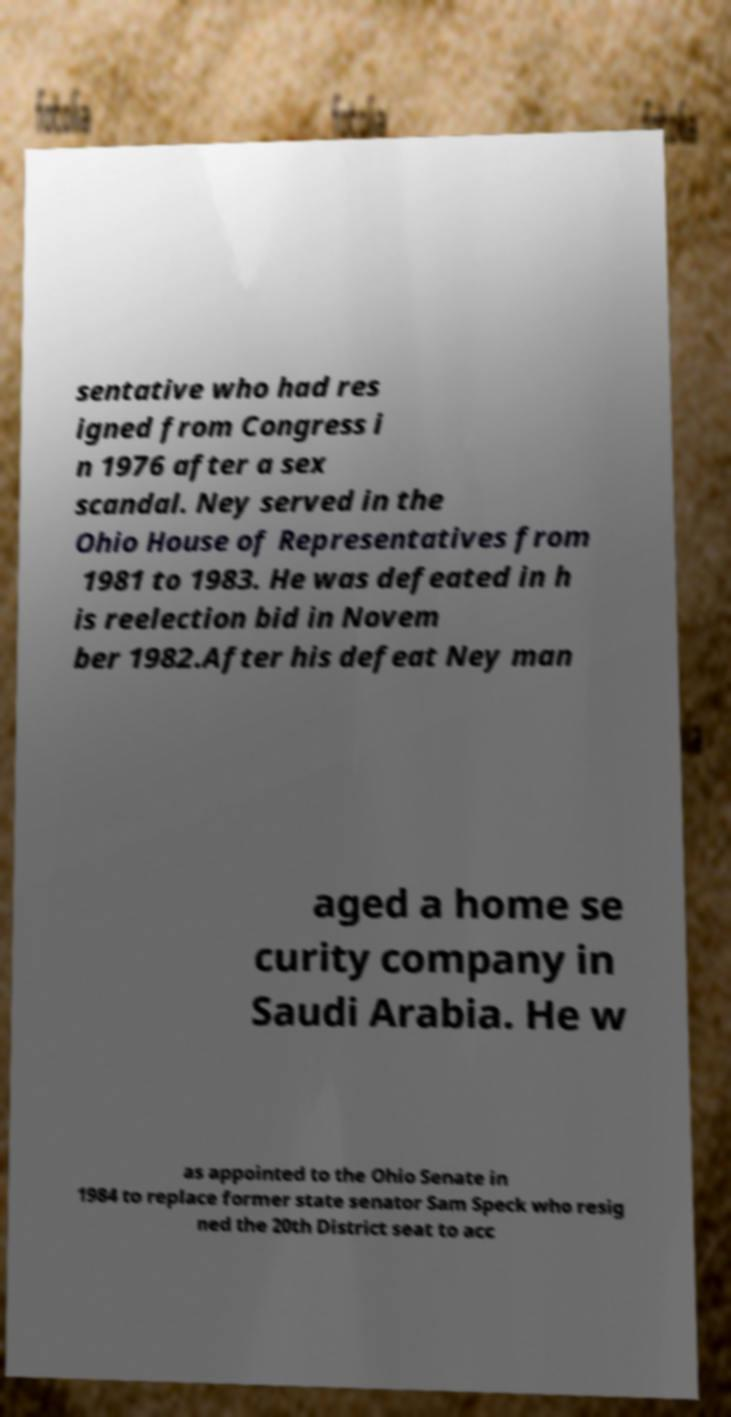Could you extract and type out the text from this image? sentative who had res igned from Congress i n 1976 after a sex scandal. Ney served in the Ohio House of Representatives from 1981 to 1983. He was defeated in h is reelection bid in Novem ber 1982.After his defeat Ney man aged a home se curity company in Saudi Arabia. He w as appointed to the Ohio Senate in 1984 to replace former state senator Sam Speck who resig ned the 20th District seat to acc 